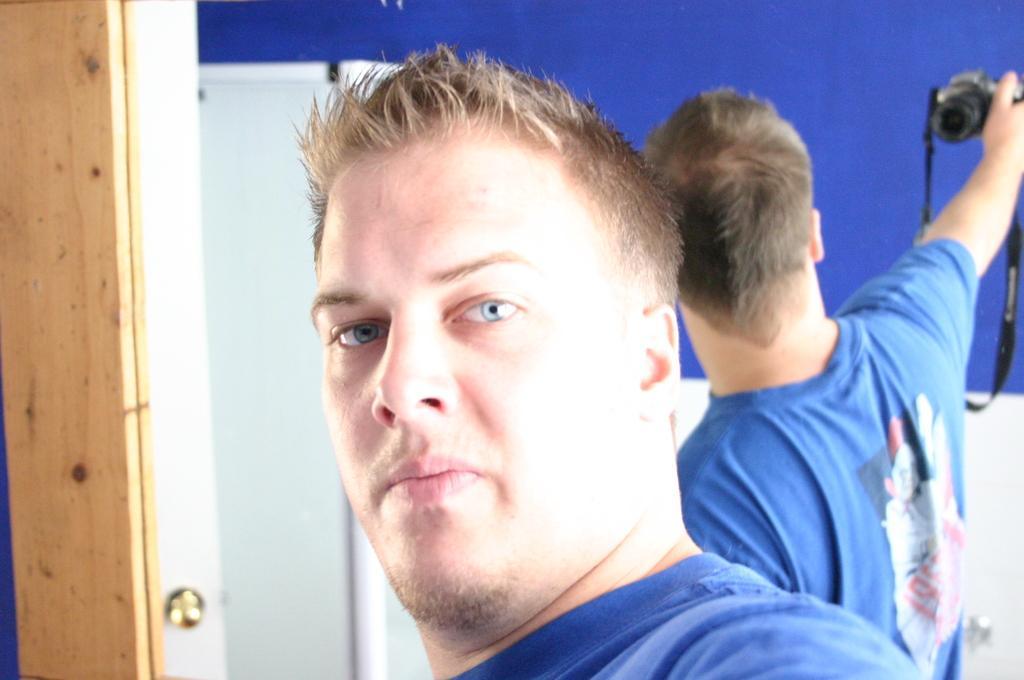Please provide a concise description of this image. In this image I can see a man and he is wearing blue colour t shirt. In the background I can see a mirror and on it I can see reflection of this man and I cant he is holding a camera. 